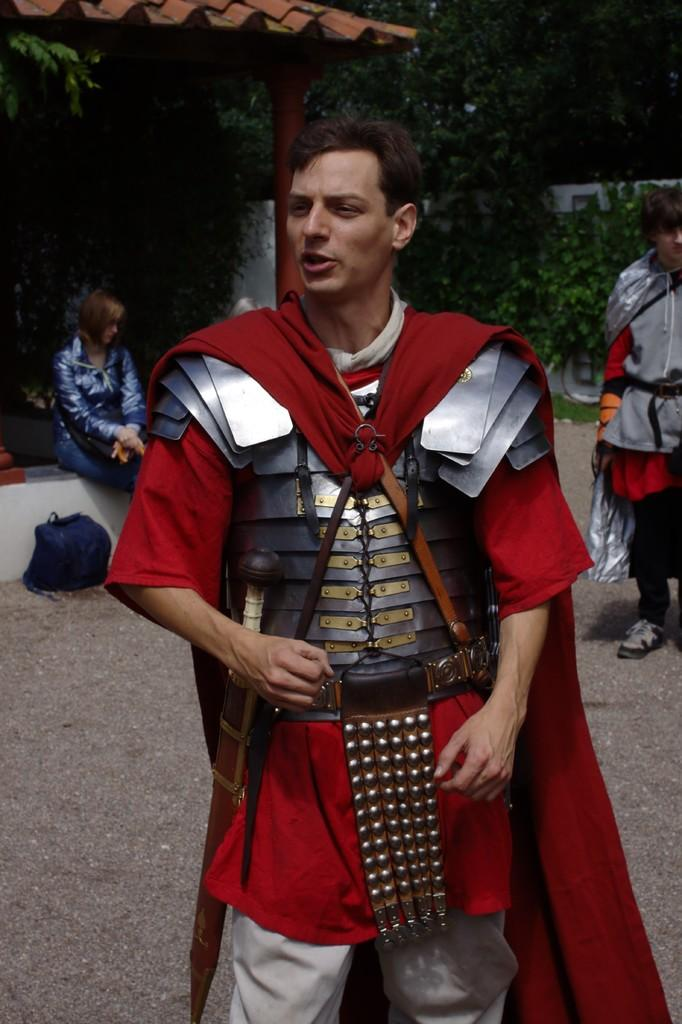What are the people in the image doing? The people in the image are standing on the ground. What are the people wearing? The people are wearing different costumes. Can you describe the woman in the image? There is a woman sitting under a roof in the image. What can be seen in the background of the scene? Trees are visible around the scene. What type of list is the beggar holding in the image? There is no beggar or list present in the image. What kind of apparatus is being used by the people in the image? There is no apparatus visible in the image; the people are simply standing on the ground and wearing costumes. 